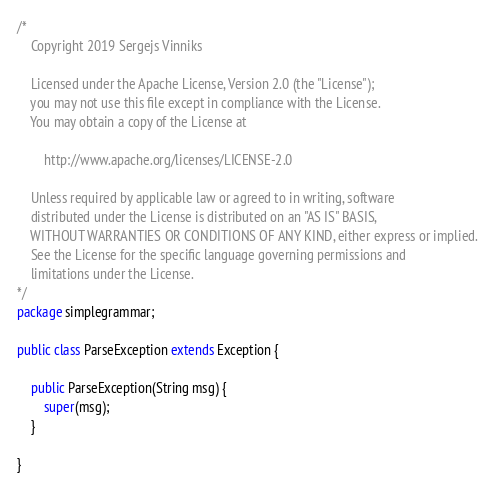Convert code to text. <code><loc_0><loc_0><loc_500><loc_500><_Java_>/*
    Copyright 2019 Sergejs Vinniks

    Licensed under the Apache License, Version 2.0 (the "License");
    you may not use this file except in compliance with the License.
    You may obtain a copy of the License at

        http://www.apache.org/licenses/LICENSE-2.0

    Unless required by applicable law or agreed to in writing, software
    distributed under the License is distributed on an "AS IS" BASIS,
    WITHOUT WARRANTIES OR CONDITIONS OF ANY KIND, either express or implied.
    See the License for the specific language governing permissions and
    limitations under the License.
*/
package simplegrammar;

public class ParseException extends Exception {

    public ParseException(String msg) {
        super(msg);
    }

}
</code> 